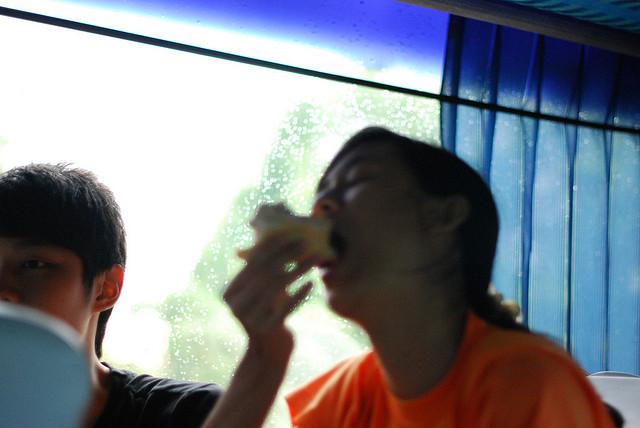Does the woman have her mouth closed?
Give a very brief answer. No. Is this woman hungry?
Concise answer only. Yes. What is covering the window?
Keep it brief. Curtain. Is this woman eating in an animated fashion?
Write a very short answer. Yes. How many doughnuts is she holding?
Keep it brief. 1. What kind of lights are in the background?
Give a very brief answer. Sunlight. 